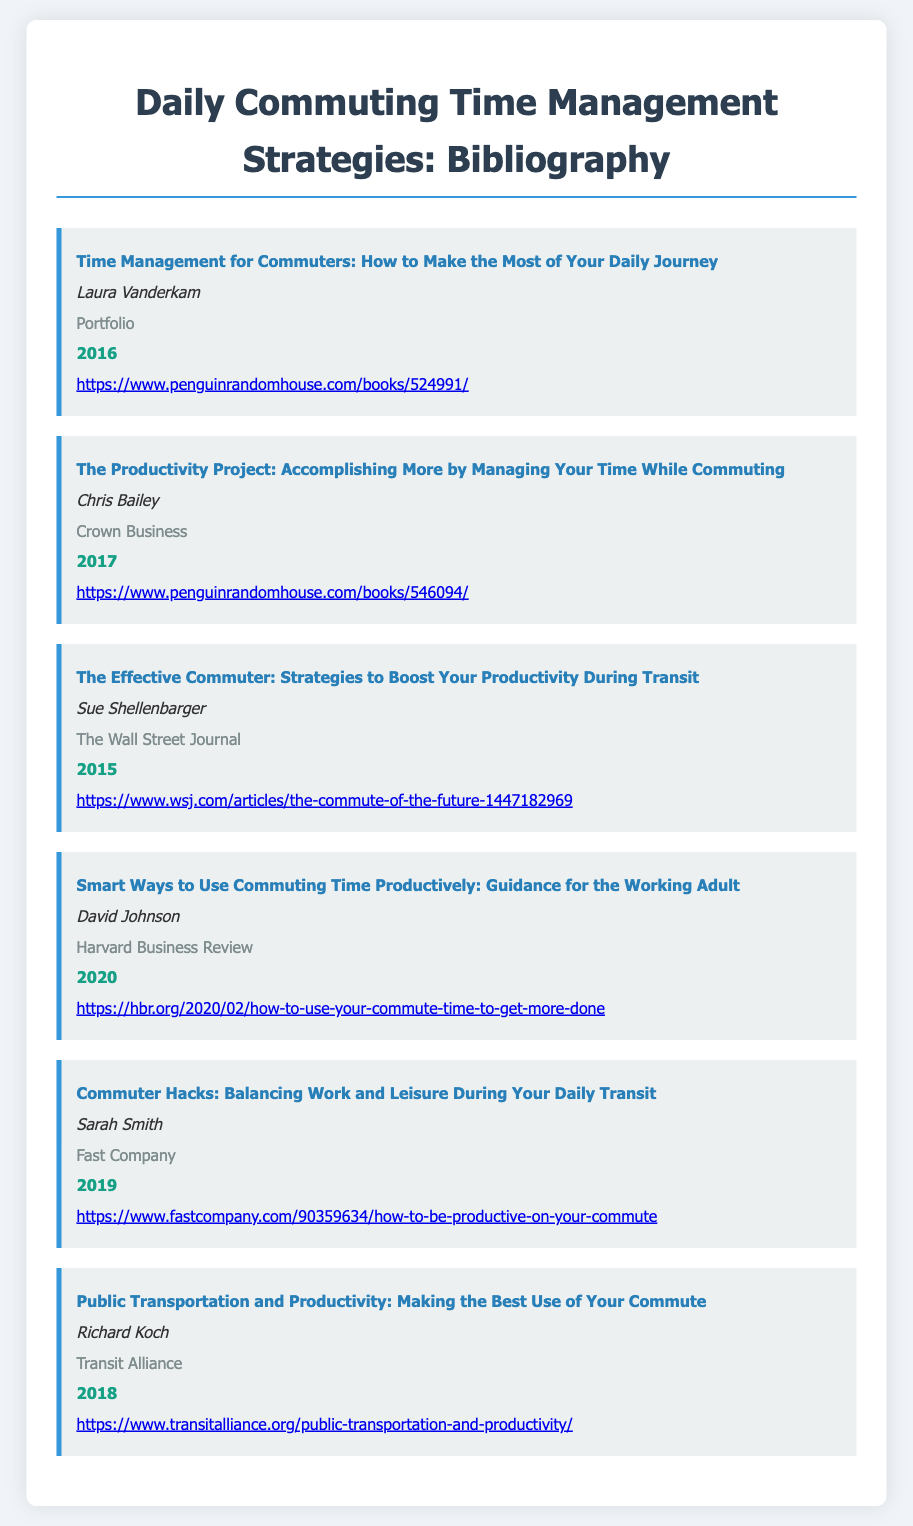What is the title of the first item in the bibliography? The title of the first item in the bibliography is "Time Management for Commuters: How to Make the Most of Your Daily Journey."
Answer: Time Management for Commuters: How to Make the Most of Your Daily Journey Who is the author of the book published by Harvard Business Review? The author of the book published by Harvard Business Review is David Johnson.
Answer: David Johnson In what year was "The Productivity Project" published? The year "The Productivity Project" was published is mentioned as 2017 in the document.
Answer: 2017 What publisher released "Commuter Hacks"? The publisher of "Commuter Hacks" is Fast Company, as listed in the document.
Answer: Fast Company Which bibliography item discusses public transportation and productivity? The item that discusses public transportation and productivity is titled "Public Transportation and Productivity: Making the Best Use of Your Commute."
Answer: Public Transportation and Productivity: Making the Best Use of Your Commute How many items are listed in the bibliography? The document contains a total of six bibliography items listed for daily commuting time management strategies.
Answer: Six 